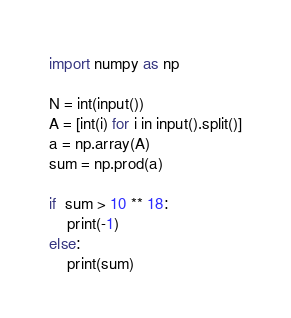<code> <loc_0><loc_0><loc_500><loc_500><_Python_>import numpy as np

N = int(input())
A = [int(i) for i in input().split()]
a = np.array(A)
sum = np.prod(a)

if  sum > 10 ** 18:
    print(-1)
else:
    print(sum)
</code> 